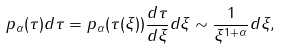Convert formula to latex. <formula><loc_0><loc_0><loc_500><loc_500>p _ { \alpha } ( \tau ) d \tau = p _ { \alpha } ( \tau ( \xi ) ) \frac { d \tau } { d \xi } d \xi \sim \frac { 1 } { \xi ^ { 1 + \alpha } } d \xi ,</formula> 